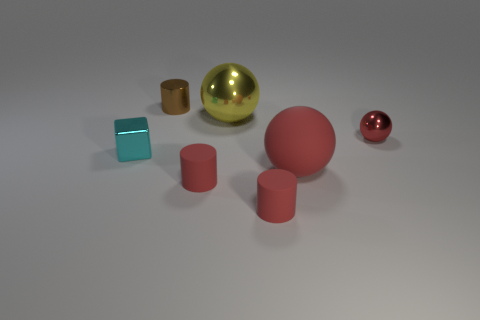Add 3 red shiny objects. How many objects exist? 10 Subtract all red rubber cylinders. How many cylinders are left? 1 Subtract all green spheres. How many red cylinders are left? 2 Subtract 1 cylinders. How many cylinders are left? 2 Subtract 0 blue spheres. How many objects are left? 7 Subtract all cylinders. How many objects are left? 4 Subtract all cyan cylinders. Subtract all green balls. How many cylinders are left? 3 Subtract all brown shiny cylinders. Subtract all big yellow shiny balls. How many objects are left? 5 Add 3 red matte cylinders. How many red matte cylinders are left? 5 Add 1 small brown spheres. How many small brown spheres exist? 1 